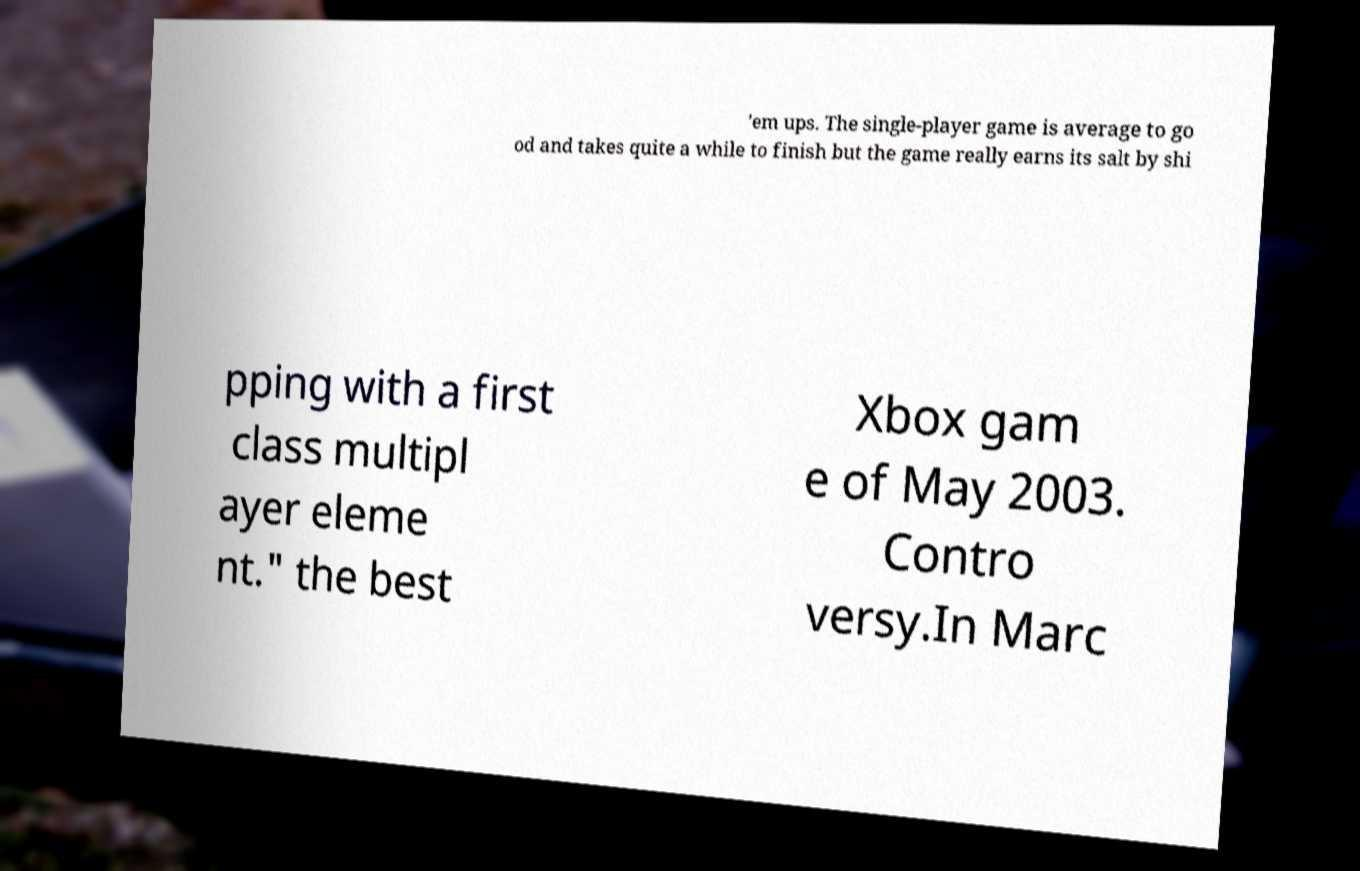Could you extract and type out the text from this image? 'em ups. The single-player game is average to go od and takes quite a while to finish but the game really earns its salt by shi pping with a first class multipl ayer eleme nt." the best Xbox gam e of May 2003. Contro versy.In Marc 